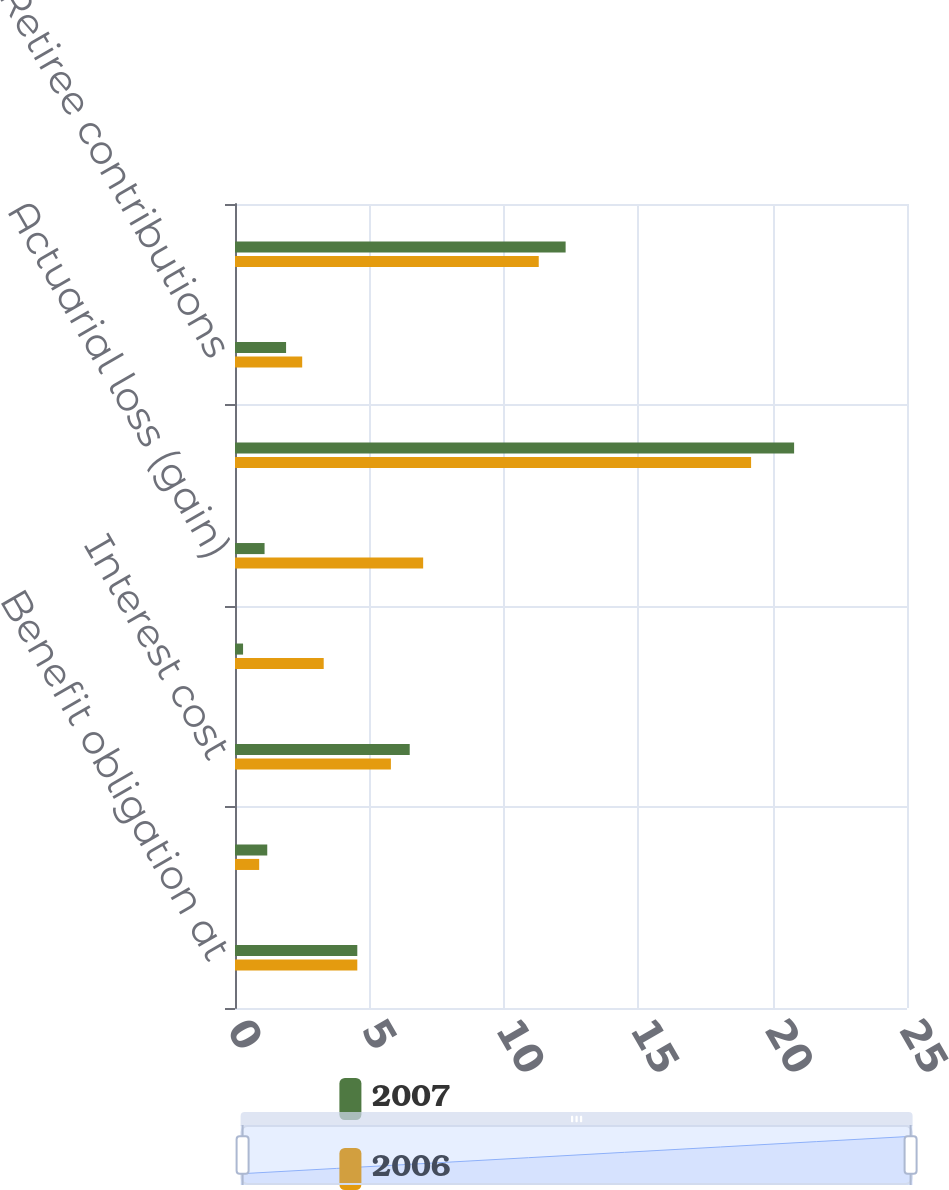Convert chart. <chart><loc_0><loc_0><loc_500><loc_500><stacked_bar_chart><ecel><fcel>Benefit obligation at<fcel>Service cost<fcel>Interest cost<fcel>Amendments and other<fcel>Actuarial loss (gain)<fcel>Acquisition<fcel>Retiree contributions<fcel>Benefits paid<nl><fcel>2007<fcel>4.55<fcel>1.2<fcel>6.5<fcel>0.3<fcel>1.1<fcel>20.8<fcel>1.9<fcel>12.3<nl><fcel>2006<fcel>4.55<fcel>0.9<fcel>5.8<fcel>3.3<fcel>7<fcel>19.2<fcel>2.5<fcel>11.3<nl></chart> 